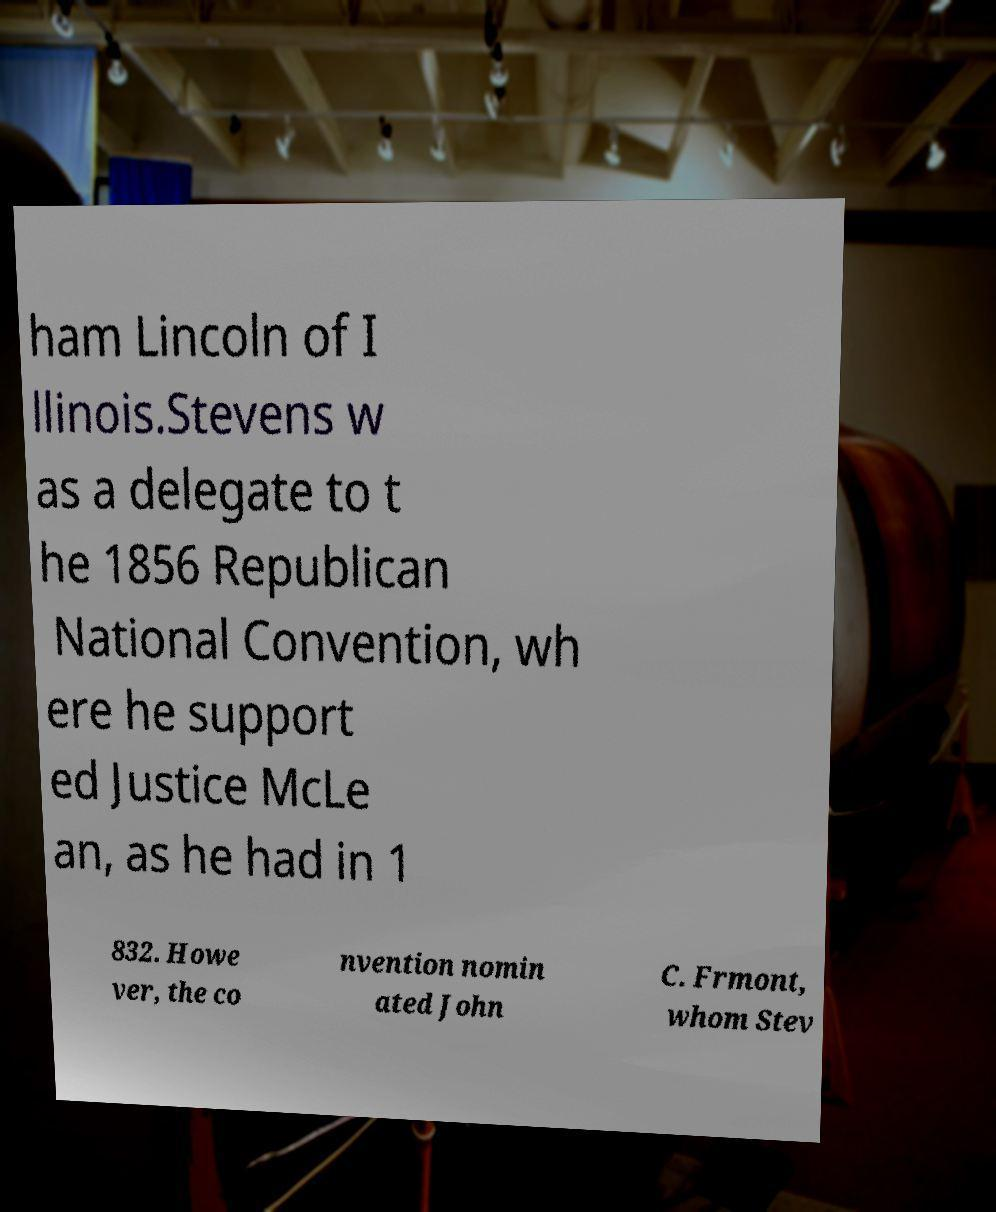Please identify and transcribe the text found in this image. ham Lincoln of I llinois.Stevens w as a delegate to t he 1856 Republican National Convention, wh ere he support ed Justice McLe an, as he had in 1 832. Howe ver, the co nvention nomin ated John C. Frmont, whom Stev 